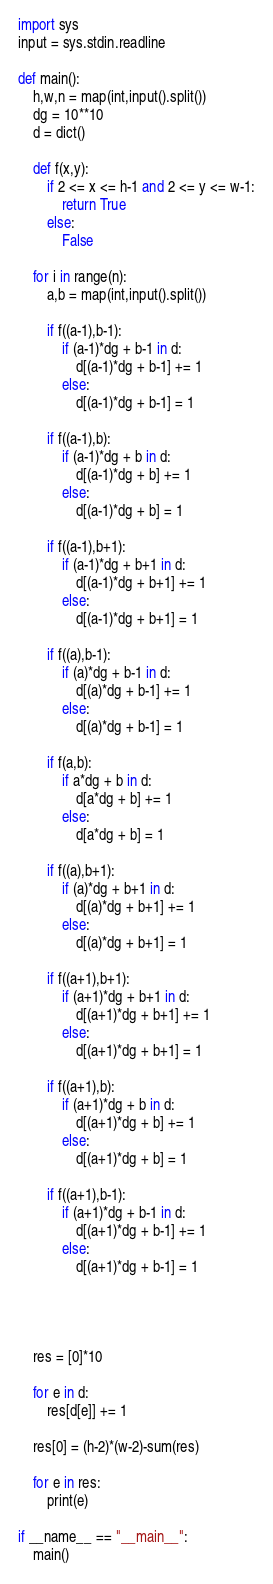<code> <loc_0><loc_0><loc_500><loc_500><_Python_>import sys
input = sys.stdin.readline

def main():
    h,w,n = map(int,input().split())
    dg = 10**10
    d = dict()

    def f(x,y):
        if 2 <= x <= h-1 and 2 <= y <= w-1:
            return True
        else:
            False

    for i in range(n):
        a,b = map(int,input().split())
        
        if f((a-1),b-1):
            if (a-1)*dg + b-1 in d:
                d[(a-1)*dg + b-1] += 1
            else:
                d[(a-1)*dg + b-1] = 1
        
        if f((a-1),b):
            if (a-1)*dg + b in d:
                d[(a-1)*dg + b] += 1
            else:
                d[(a-1)*dg + b] = 1
        
        if f((a-1),b+1):
            if (a-1)*dg + b+1 in d:
                d[(a-1)*dg + b+1] += 1
            else:
                d[(a-1)*dg + b+1] = 1

        if f((a),b-1):
            if (a)*dg + b-1 in d:
                d[(a)*dg + b-1] += 1
            else:
                d[(a)*dg + b-1] = 1
        
        if f(a,b):
            if a*dg + b in d:
                d[a*dg + b] += 1
            else:
                d[a*dg + b] = 1
        
        if f((a),b+1):
            if (a)*dg + b+1 in d:
                d[(a)*dg + b+1] += 1
            else:
                d[(a)*dg + b+1] = 1
        
        if f((a+1),b+1):
            if (a+1)*dg + b+1 in d:
                d[(a+1)*dg + b+1] += 1
            else:
                d[(a+1)*dg + b+1] = 1
        
        if f((a+1),b):
            if (a+1)*dg + b in d:
                d[(a+1)*dg + b] += 1
            else:
                d[(a+1)*dg + b] = 1
        
        if f((a+1),b-1):
            if (a+1)*dg + b-1 in d:
                d[(a+1)*dg + b-1] += 1
            else:
                d[(a+1)*dg + b-1] = 1
        
        
        
        
    res = [0]*10
 
    for e in d:
        res[d[e]] += 1
 
    res[0] = (h-2)*(w-2)-sum(res)
 
    for e in res:
        print(e)
 
if __name__ == "__main__":
    main()
</code> 